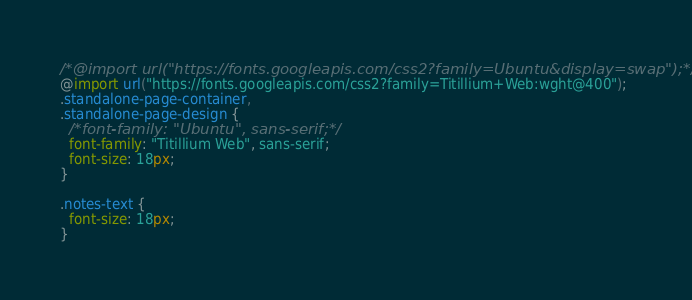Convert code to text. <code><loc_0><loc_0><loc_500><loc_500><_CSS_>/*@import url("https://fonts.googleapis.com/css2?family=Ubuntu&display=swap");*/
@import url("https://fonts.googleapis.com/css2?family=Titillium+Web:wght@400");
.standalone-page-container,
.standalone-page-design {
  /*font-family: "Ubuntu", sans-serif;*/
  font-family: "Titillium Web", sans-serif;
  font-size: 18px;
}

.notes-text {
  font-size: 18px;
}
</code> 